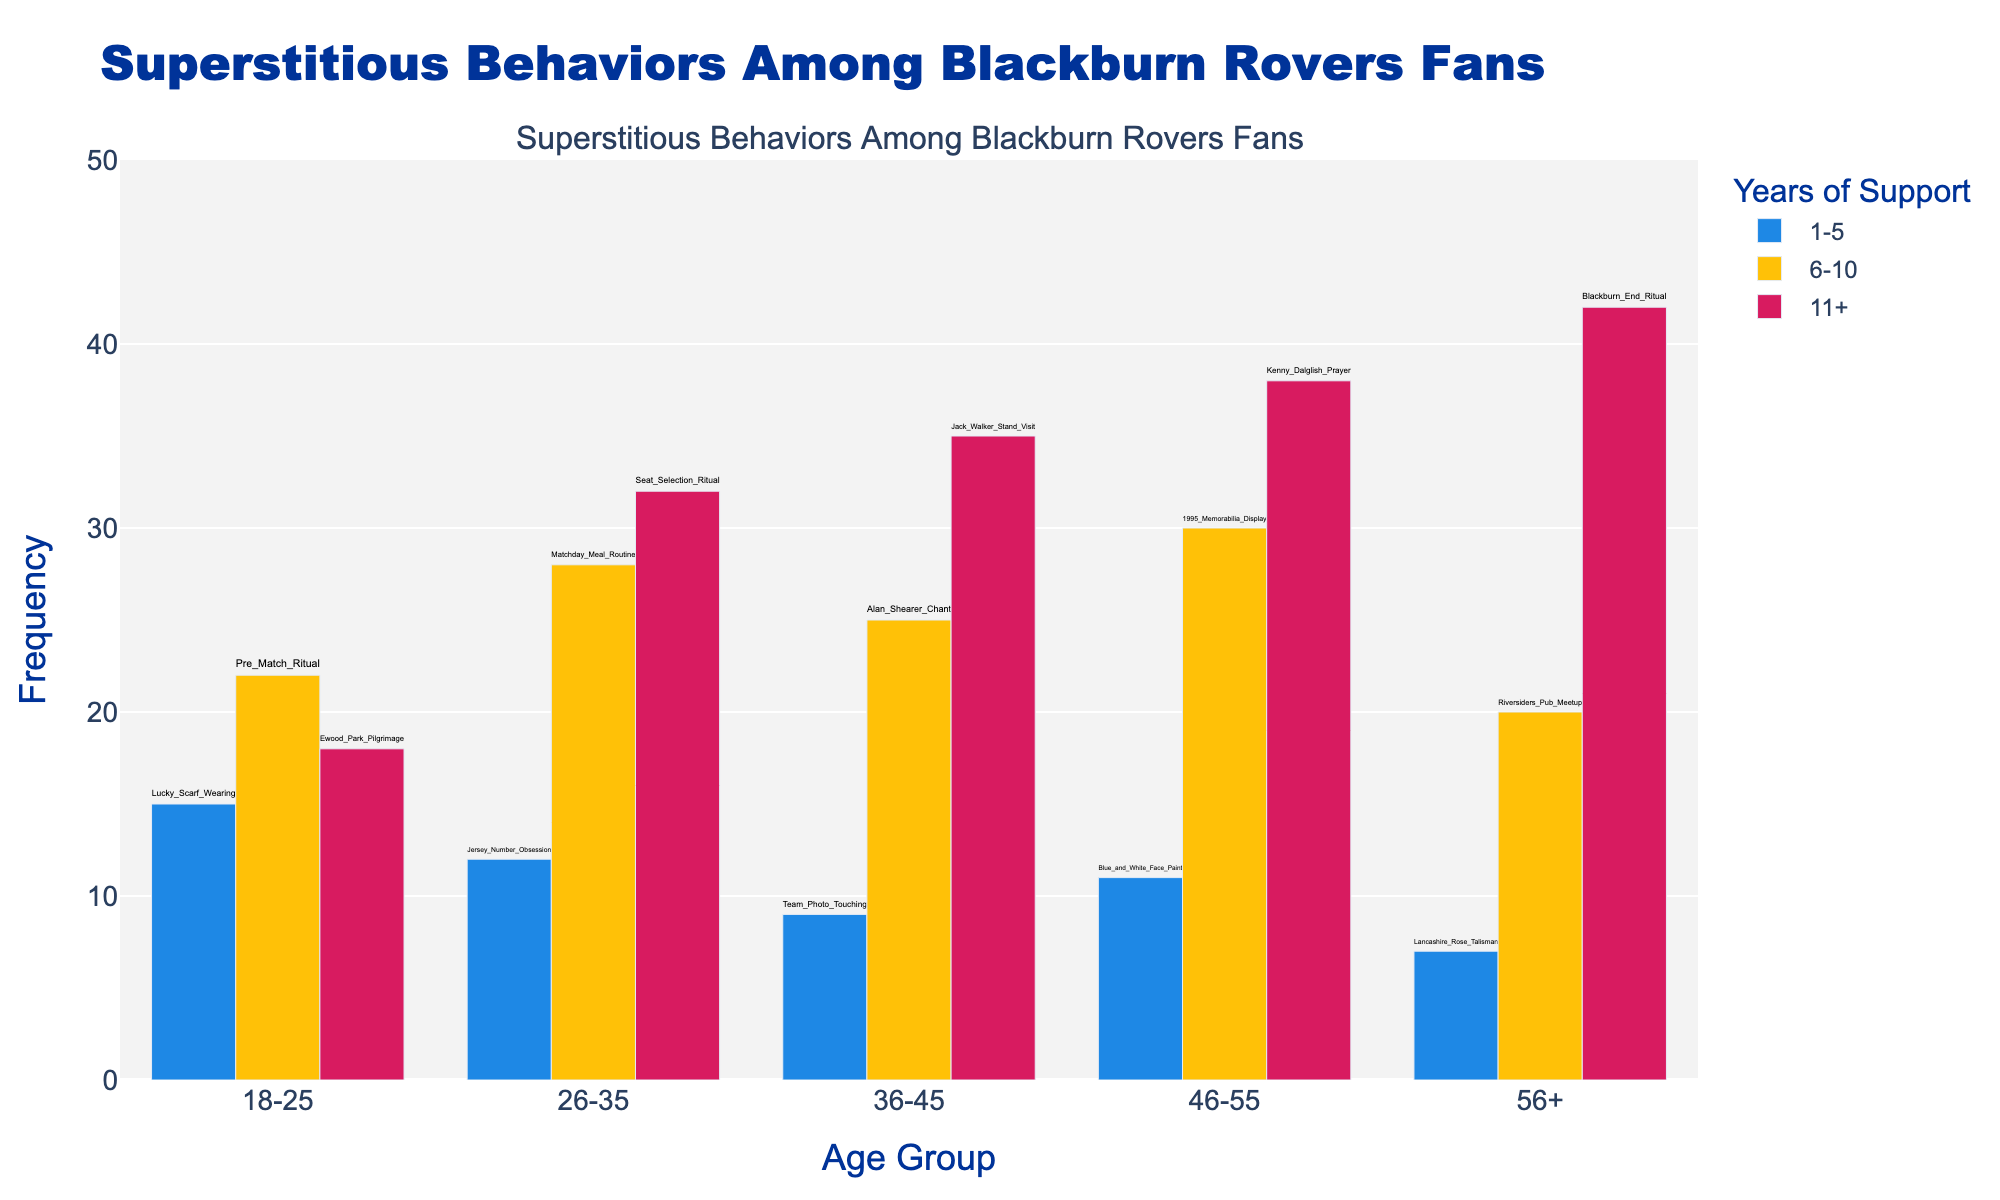What's the title of the figure? The title of the figure is displayed at the top of the chart and it reads "Superstitious Behaviors Among Blackburn Rovers Fans".
Answer: Superstitious Behaviors Among Blackburn Rovers Fans What are the x-axis and y-axis labels in the figure? The labels for the axes can be found adjacent to the axes themselves. The x-axis is labeled as "Age Group" and the y-axis is labeled as "Frequency".
Answer: Age Group, Frequency Which age group shows the highest frequency of superstitious behaviors among fans who have supported the team for 11+ years? To find this, look at the bars colored for "11+" years in each age group. The highest bar is in the 56+ age group.
Answer: 56+ What superstition has the highest frequency for fans aged 36-45 with 11+ years of support? Check the label for the bar representing the 36-45 age group and 11+ years. The bar with the highest frequency corresponds to "Jack Walker Stand Visit" with a frequency of 35.
Answer: Jack Walker Stand Visit For fans aged 18-25, which superstition is most frequent and what is its frequency? Look for the highest bar in the 18-25 age group, regardless of years of support. The highest frequency is for "Pre Match Ritual" with a value of 22.
Answer: Pre Match Ritual, 22 Which age group has the lowest frequency for the superstition "Team Photo Touching"? Identify the bar annotated with "Team Photo Touching". It is in the 36-45 age group and has a frequency of 9. This is the lowest frequency.
Answer: 36-45 What is the total frequency of superstitious behaviors for the age group 26-35? Sum the frequencies of all superstitions within the age group 26-35. The values are 12, 28, and 32, leading to a total of 72.
Answer: 72 How does the frequency of "Lucky Scarf Wearing" compare to "Lancashire Rose Talisman"? Compare the height of the bars corresponding to these superstitions. "Lucky Scarf Wearing" in the 18-25 age group has a frequency of 15, while "Lancashire Rose Talisman" in the 56+ age group has a frequency of 7. "Lucky Scarf Wearing" is higher.
Answer: Lucky Scarf Wearing is higher Which superstition is unique to fans aged 46-55 and supported for 11+ years? This can be found by checking for unique labels in the 46-55 age group with 11+ years. The superstition is "Kenny Dalglish Prayer".
Answer: Kenny Dalglish Prayer Calculate the average frequency of superstitions for the age group 56+ across all years of support. Sum the frequencies for the 56+ age group and divide by the number of data points: (7+20+42)/3 = 23.
Answer: 23 